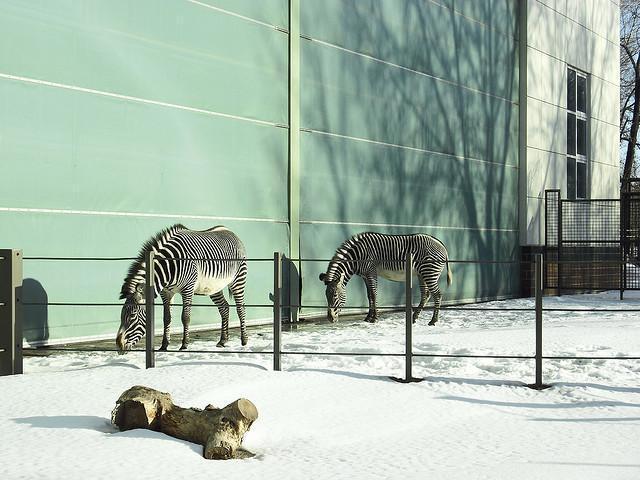How many zebras are in the scene?
Give a very brief answer. 2. How many zebras can you see?
Give a very brief answer. 2. 